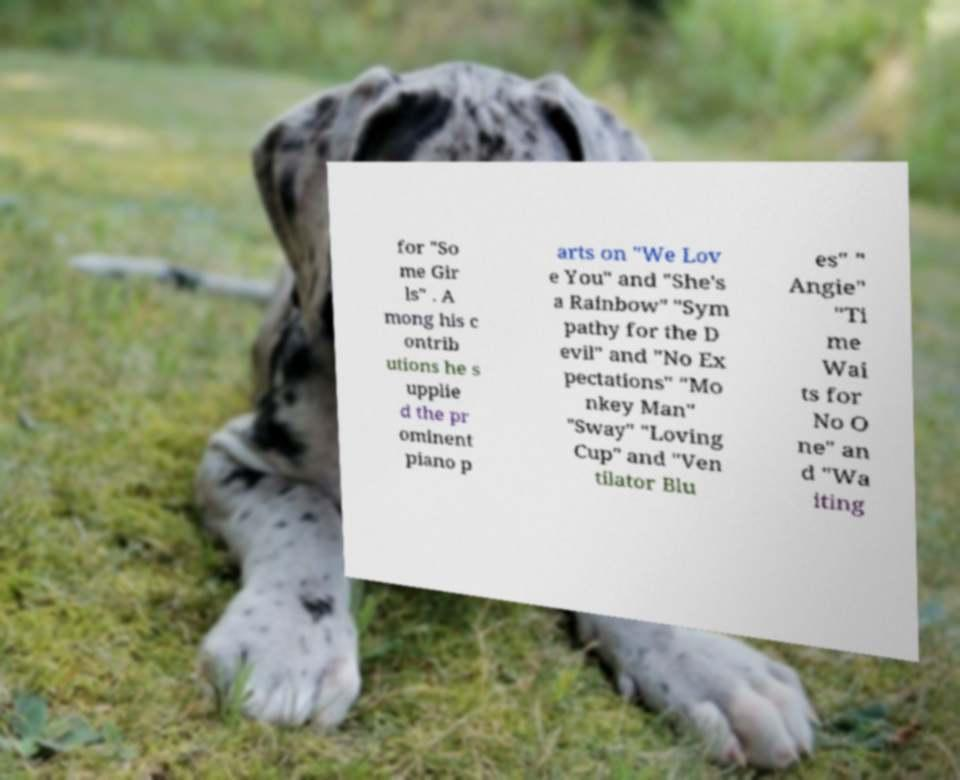What messages or text are displayed in this image? I need them in a readable, typed format. for "So me Gir ls" . A mong his c ontrib utions he s upplie d the pr ominent piano p arts on "We Lov e You" and "She's a Rainbow" "Sym pathy for the D evil" and "No Ex pectations" "Mo nkey Man" "Sway" "Loving Cup" and "Ven tilator Blu es" " Angie" "Ti me Wai ts for No O ne" an d "Wa iting 